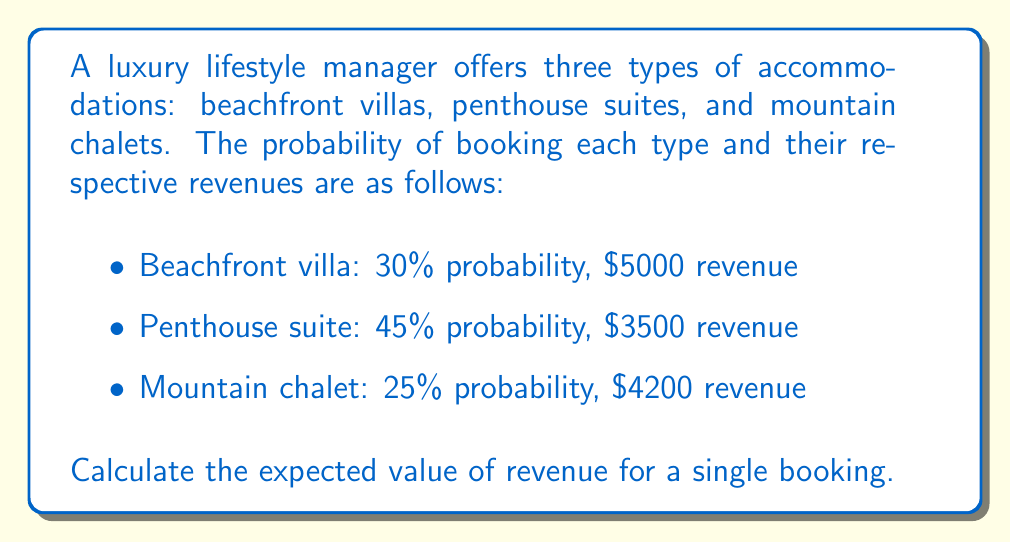What is the answer to this math problem? To calculate the expected value of revenue, we need to multiply each possible revenue by its probability and then sum these products.

Let's define our random variable X as the revenue from a single booking.

Step 1: Calculate the expected value for each accommodation type:

1. Beachfront villa:
   $E(X_{villa}) = 0.30 \times \$5000 = \$1500$

2. Penthouse suite:
   $E(X_{suite}) = 0.45 \times \$3500 = \$1575$

3. Mountain chalet:
   $E(X_{chalet}) = 0.25 \times \$4200 = \$1050$

Step 2: Sum the expected values to get the total expected value:

$$E(X) = E(X_{villa}) + E(X_{suite}) + E(X_{chalet})$$
$$E(X) = \$1500 + \$1575 + \$1050 = \$4125$$

Therefore, the expected value of revenue for a single booking is $4125.
Answer: $4125 